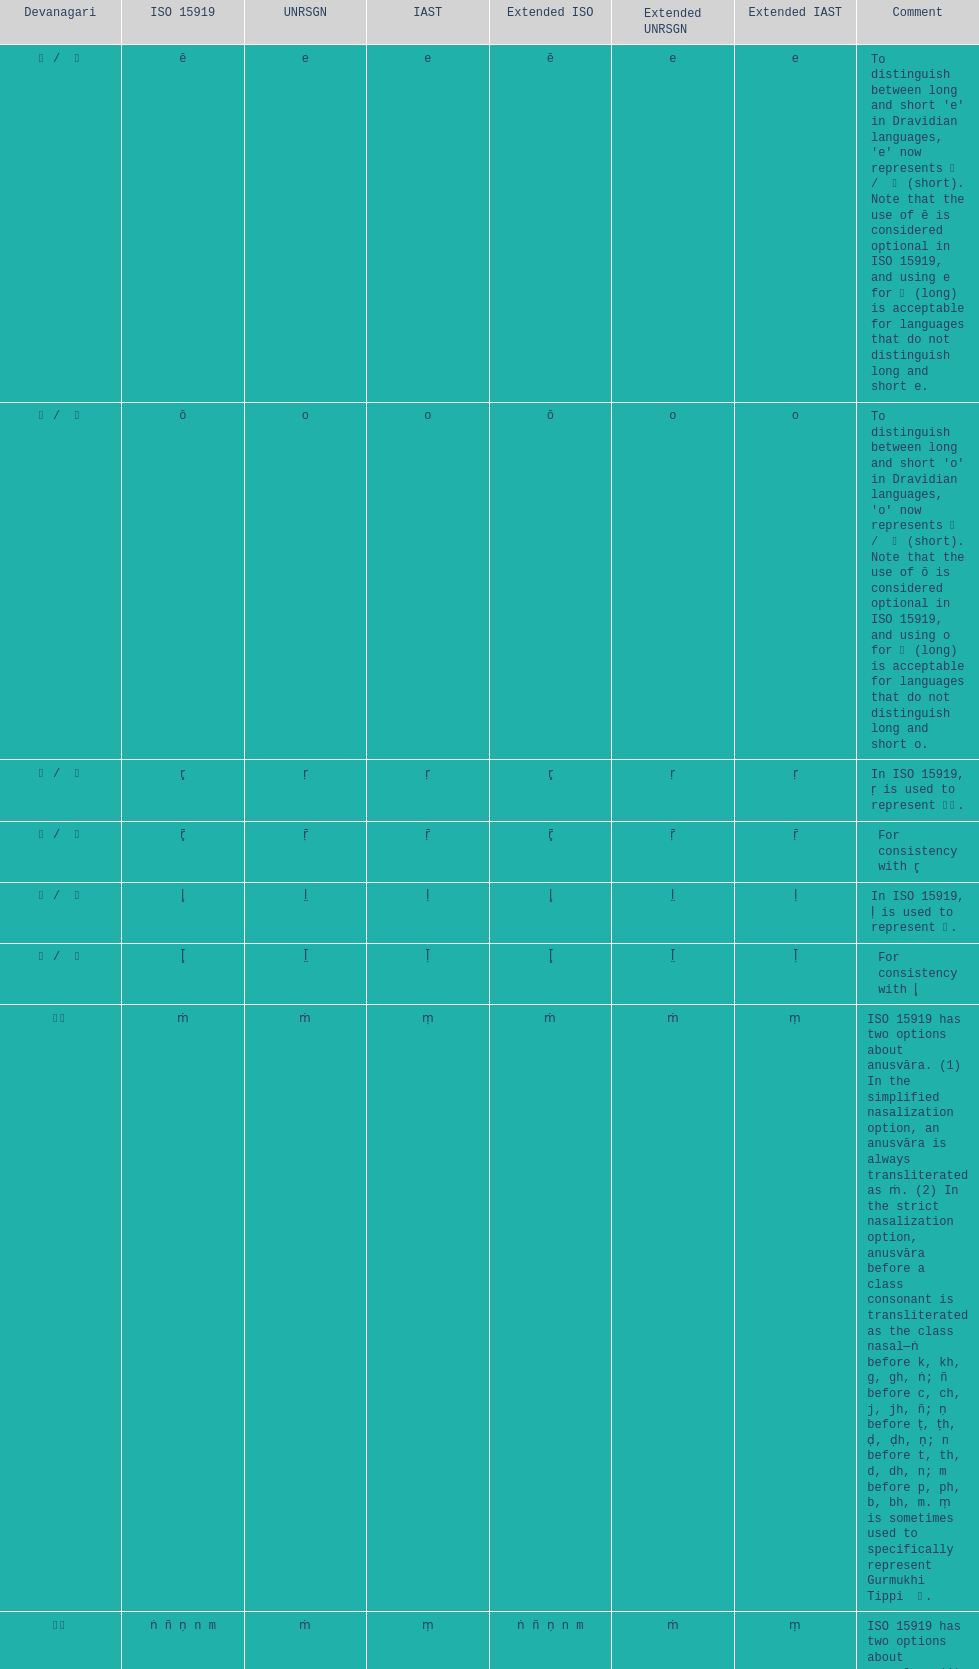What unrsgn is listed previous to the o? E. 